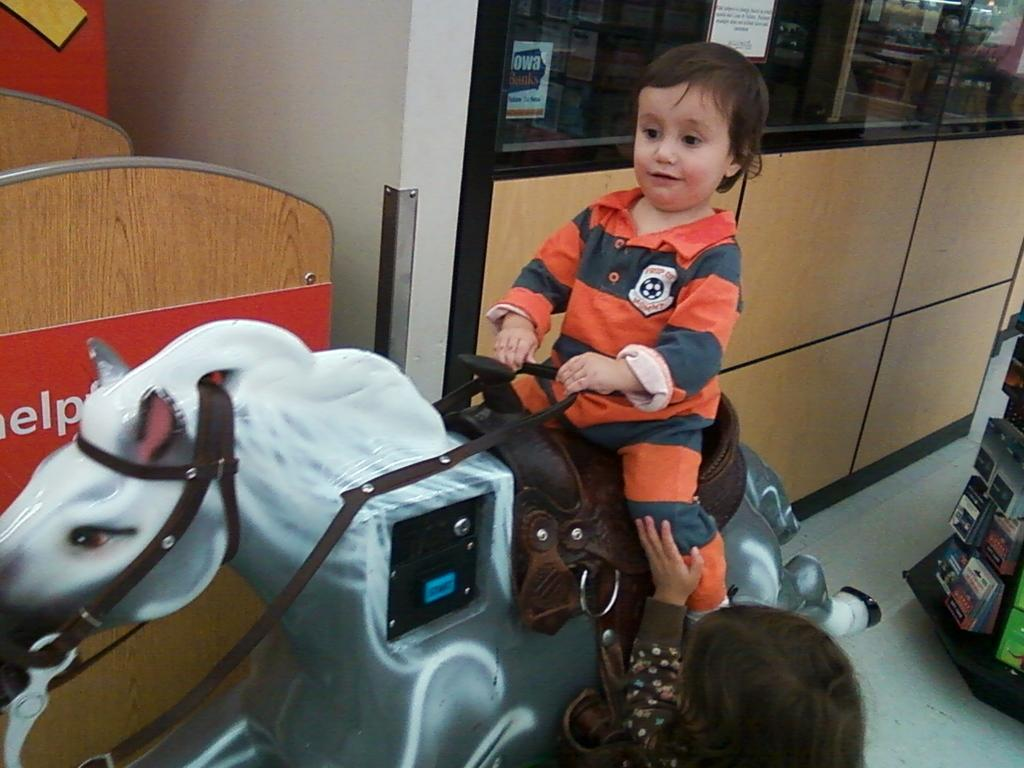What is the color of the wall in the image? The wall in the image is white. What type of furniture can be seen in the image? There are cupboards in the image. What is the boy doing in the image? The boy is sitting on a toy horse in the image. What type of celery is the boy eating in the image? There is no celery present in the image; the boy is sitting on a toy horse. What type of competition is the boy participating in while sitting on the toy horse? There is no competition present in the image; the boy is simply sitting on a toy horse. 